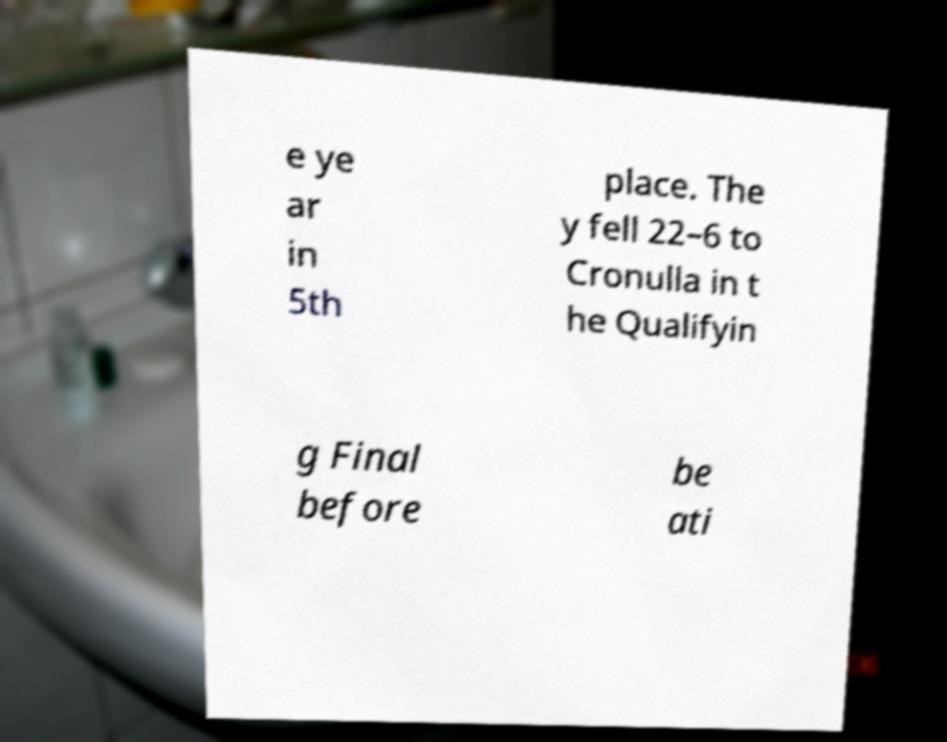Please identify and transcribe the text found in this image. e ye ar in 5th place. The y fell 22–6 to Cronulla in t he Qualifyin g Final before be ati 